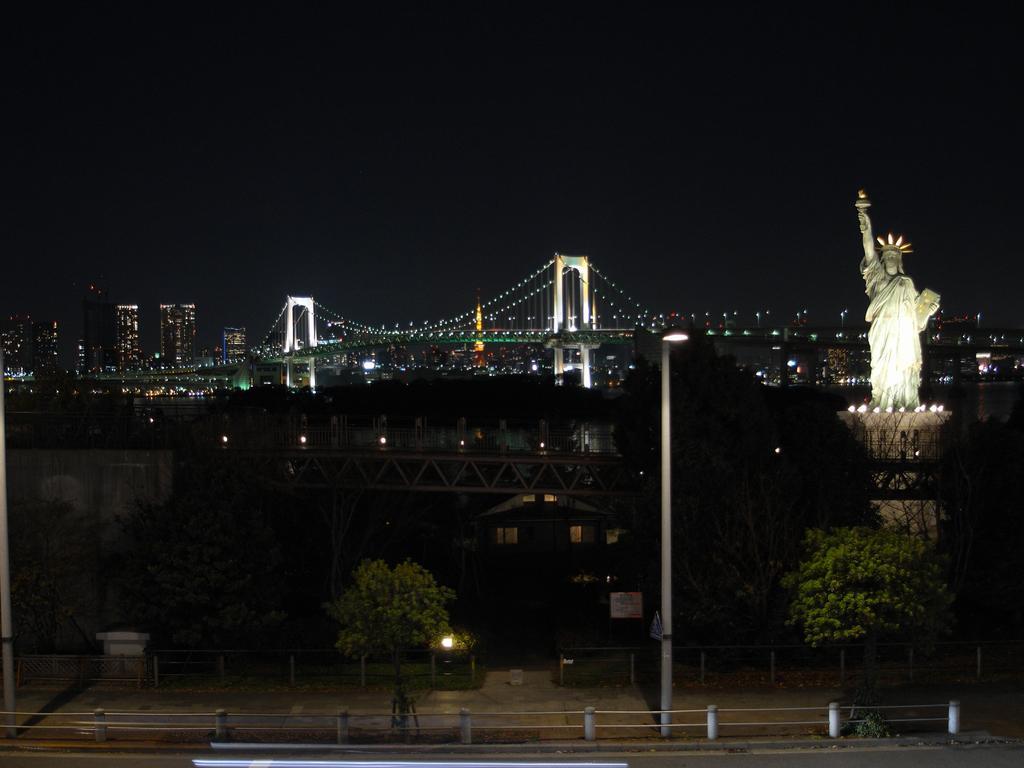How would you summarize this image in a sentence or two? In this image in the foreground there is a pole, at the bottom of the image there is walkway and railing. And on the left side of the image there is a statue, and also we could see some trees, walkway, lights, bridgewater, poles, buildings, wall and some objects. At the top there is sky. 